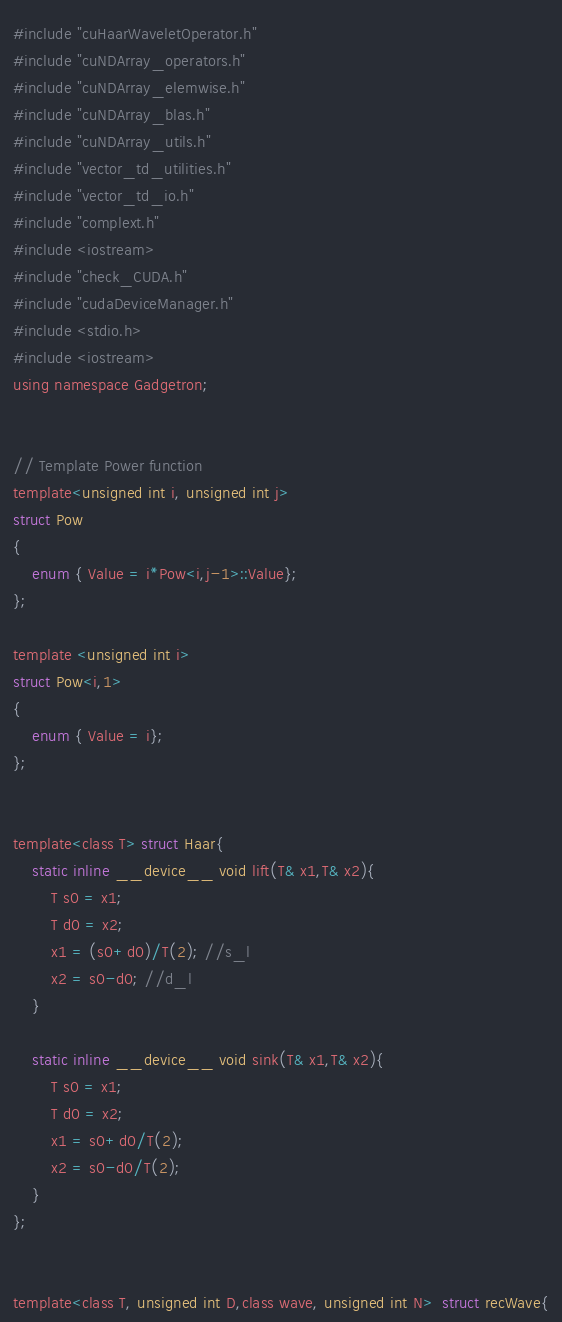<code> <loc_0><loc_0><loc_500><loc_500><_Cuda_>#include "cuHaarWaveletOperator.h"
#include "cuNDArray_operators.h"
#include "cuNDArray_elemwise.h"
#include "cuNDArray_blas.h"
#include "cuNDArray_utils.h"
#include "vector_td_utilities.h"
#include "vector_td_io.h"
#include "complext.h"
#include <iostream>
#include "check_CUDA.h"
#include "cudaDeviceManager.h"
#include <stdio.h>
#include <iostream>
using namespace Gadgetron;


// Template Power function
template<unsigned int i, unsigned int j>
struct Pow
{
	enum { Value = i*Pow<i,j-1>::Value};
};

template <unsigned int i>
struct Pow<i,1>
{
	enum { Value = i};
};


template<class T> struct Haar{
	static inline __device__ void lift(T& x1,T& x2){
		T s0 = x1;
		T d0 = x2;
		x1 = (s0+d0)/T(2); //s_l
		x2 = s0-d0; //d_l
	}

	static inline __device__ void sink(T& x1,T& x2){
		T s0 = x1;
		T d0 = x2;
		x1 = s0+d0/T(2);
		x2 = s0-d0/T(2);
	}
};


template<class T, unsigned int D,class wave, unsigned int N>  struct recWave{
</code> 